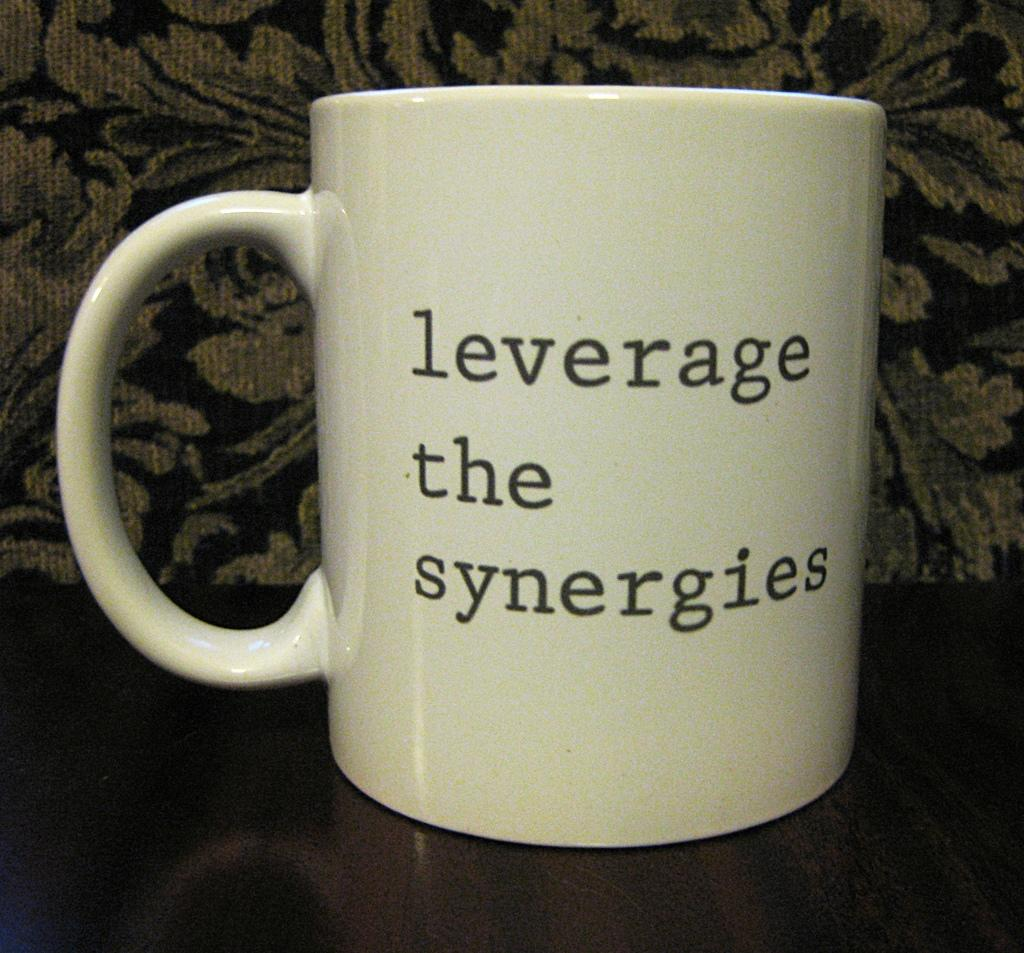<image>
Summarize the visual content of the image. The words leverage the synergies written on a cup. 